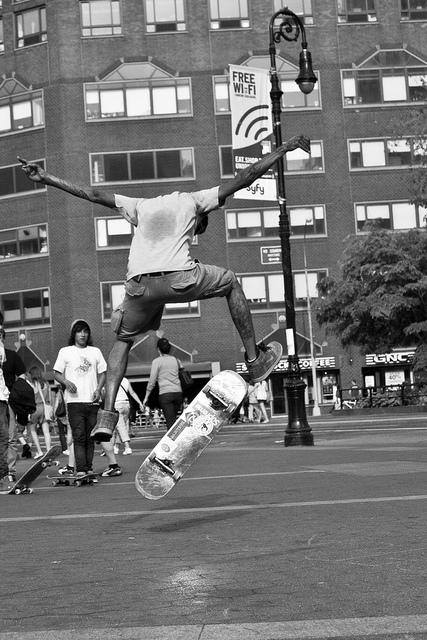What type of goods are sold in the store next to the tree?

Choices:
A) baked goods
B) coffee
C) nutritional supplements
D) pizza nutritional supplements 